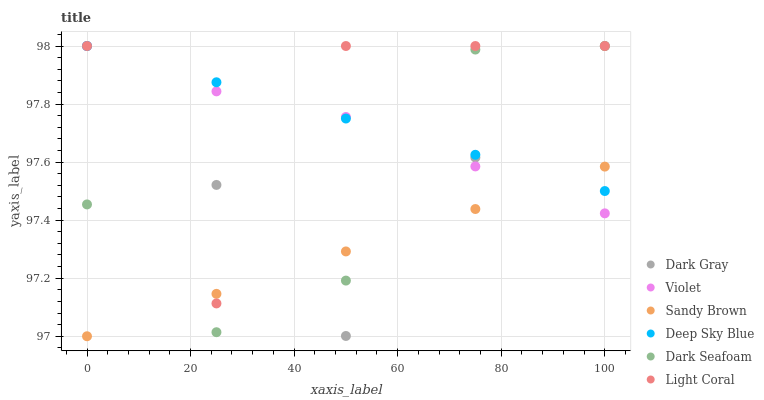Does Sandy Brown have the minimum area under the curve?
Answer yes or no. Yes. Does Light Coral have the maximum area under the curve?
Answer yes or no. Yes. Does Dark Gray have the minimum area under the curve?
Answer yes or no. No. Does Dark Gray have the maximum area under the curve?
Answer yes or no. No. Is Sandy Brown the smoothest?
Answer yes or no. Yes. Is Light Coral the roughest?
Answer yes or no. Yes. Is Dark Gray the smoothest?
Answer yes or no. No. Is Dark Gray the roughest?
Answer yes or no. No. Does Sandy Brown have the lowest value?
Answer yes or no. Yes. Does Dark Gray have the lowest value?
Answer yes or no. No. Does Violet have the highest value?
Answer yes or no. Yes. Does Sandy Brown have the highest value?
Answer yes or no. No. Does Light Coral intersect Dark Gray?
Answer yes or no. Yes. Is Light Coral less than Dark Gray?
Answer yes or no. No. Is Light Coral greater than Dark Gray?
Answer yes or no. No. 